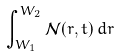Convert formula to latex. <formula><loc_0><loc_0><loc_500><loc_500>\int _ { W _ { 1 } } ^ { W _ { 2 } } \mathcal { N } ( r , t ) \, d r</formula> 